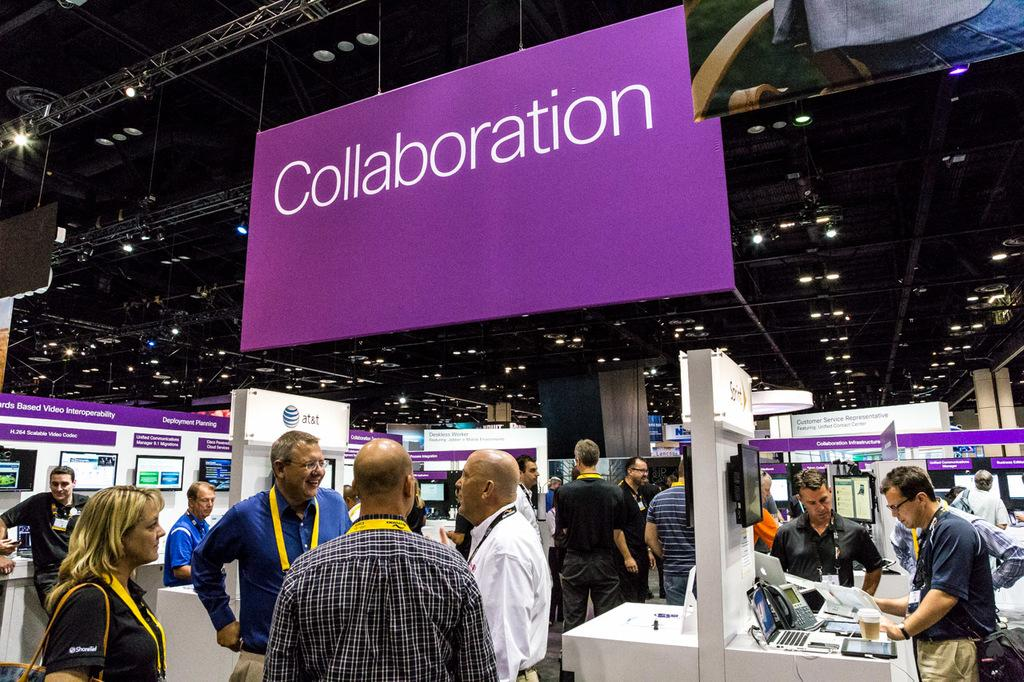<image>
Present a compact description of the photo's key features. An event of some sort with a sign saying collaboration 